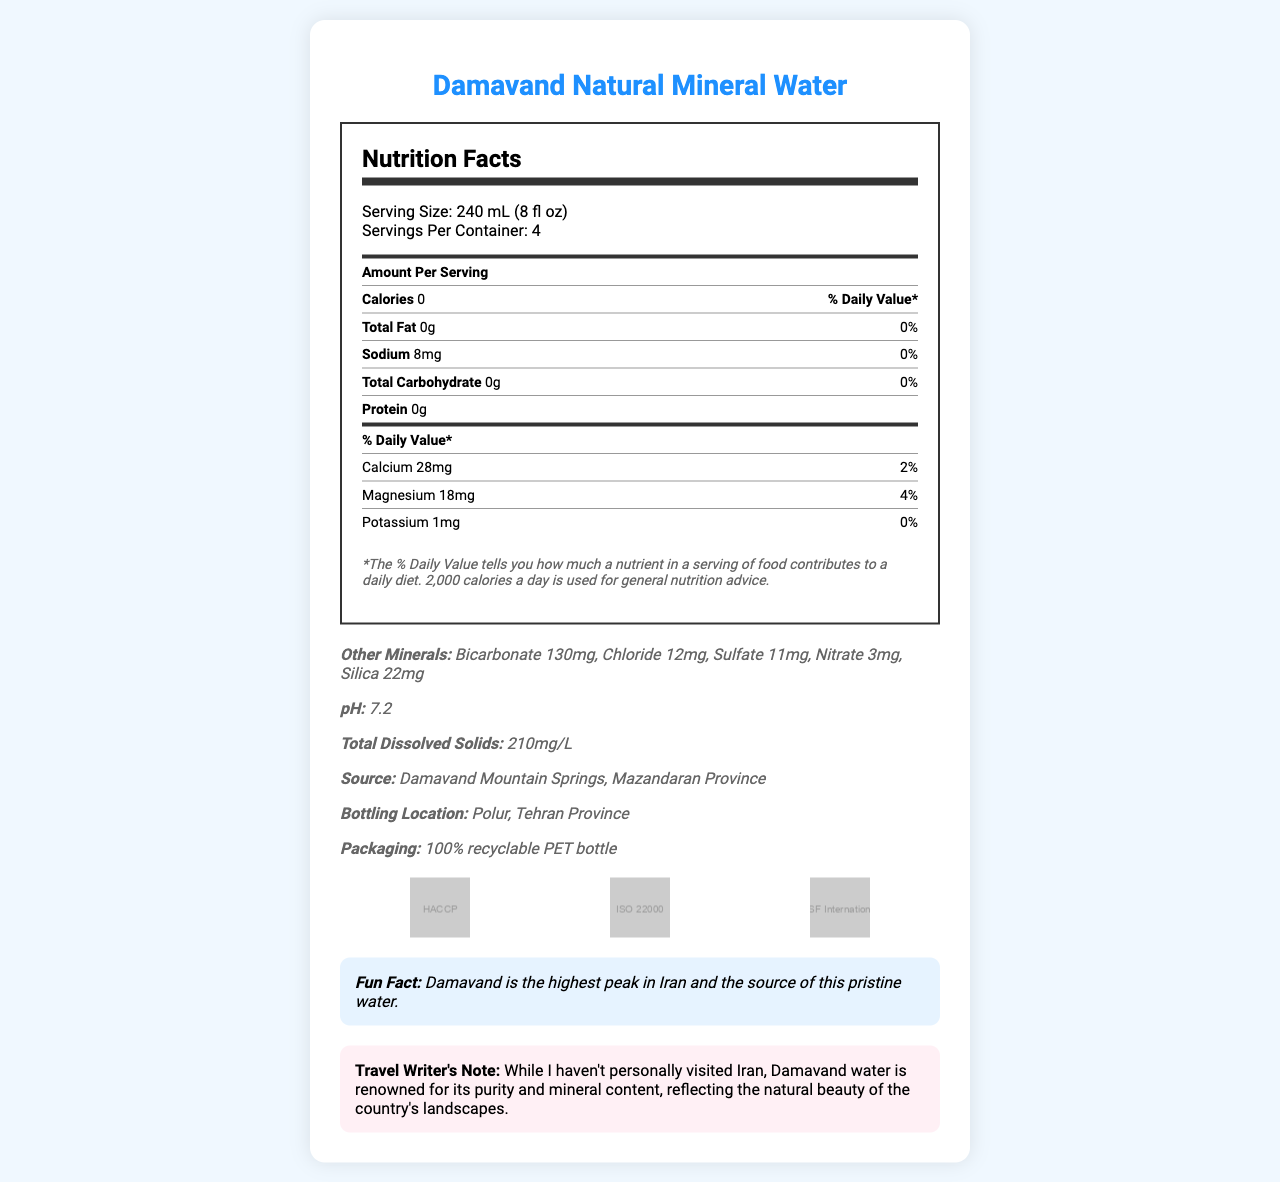What is the serving size of Damavand Natural Mineral Water? The serving size is clearly mentioned in the document as "240 mL (8 fl oz)".
Answer: 240 mL (8 fl oz) How much sodium is in one serving of Damavand Natural Mineral Water? The Nutrition Facts label lists sodium content as 8 mg per serving.
Answer: 8 mg How many servings are in one container? The document states that there are 4 servings per container.
Answer: 4 What is the total amount of calcium in one serving? Under the section "Amount Per Serving," calcium is listed as 28 mg.
Answer: 28 mg What certifications does Damavand Natural Mineral Water have? The certifications are listed at the bottom of the document with icons representing each certification.
Answer: HACCP, ISO 22000, NSF International What is the pH level of Damavand Natural Mineral Water? The pH value is explicitly mentioned as 7.2 in the document.
Answer: 7.2 Where is the source of Damavand Natural Mineral Water? The source is stated as Damavand Mountain Springs, Mazandaran Province.
Answer: Damavand Mountain Springs, Mazandaran Province Which mineral has the highest amount in Damavand Natural Mineral Water? A. Calcium B. Bicarbonate C. Sodium D. Silica According to the document, bicarbonate has the highest amount at 130 mg per serving.
Answer: B What is the bottling location of this bottled water? A. Mazandaran Province B. Tehran Province C. Esfahan Province The bottling location is listed as Polur, Tehran Province.
Answer: B Is the packaging of Damavand Natural Mineral Water recyclable? The document mentions that the packaging is made of 100% recyclable PET bottle.
Answer: Yes Does Damavand Natural Mineral Water contain any calories? The Nutrition Facts label lists the calorie content as 0, meaning the water contains no calories.
Answer: No Summarize the main idea of the document. The main idea focuses on presenting comprehensive nutritional details for Damavand Natural Mineral Water, emphasizing its purity, mineral content, and environmentally friendly packaging.
Answer: The document provides detailed nutritional information about Damavand Natural Mineral Water, highlighting the mineral content, serving size, certifications, and packaging. It indicates that the water is sourced from Damavand Mountain Springs and bottled in Tehran Province, with a notable feature being its recyclable packaging and high mineral content. What is the daily value percentage of magnesium in one serving? The document shows that magnesium has a 4% daily value per serving.
Answer: 4% Can the nutritional information of this water help determine its taste? The nutritional information provides data on mineral content and other aspects but does not give any details about the taste.
Answer: No What fun fact is mentioned about Damavand Natural Mineral Water? The document includes a fun fact stating that Damavand is the highest peak in Iran and the source of this water.
Answer: Damavand is the highest peak in Iran and the source of this pristine water. What is the travel writer's note? The document has a specific section where the travel writer notes the water's purity and connection to Iran's landscapes, despite not having visited the country.
Answer: While I haven't personally visited Iran, Damavand water is renowned for its purity and mineral content, reflecting the natural beauty of the country's landscapes. 